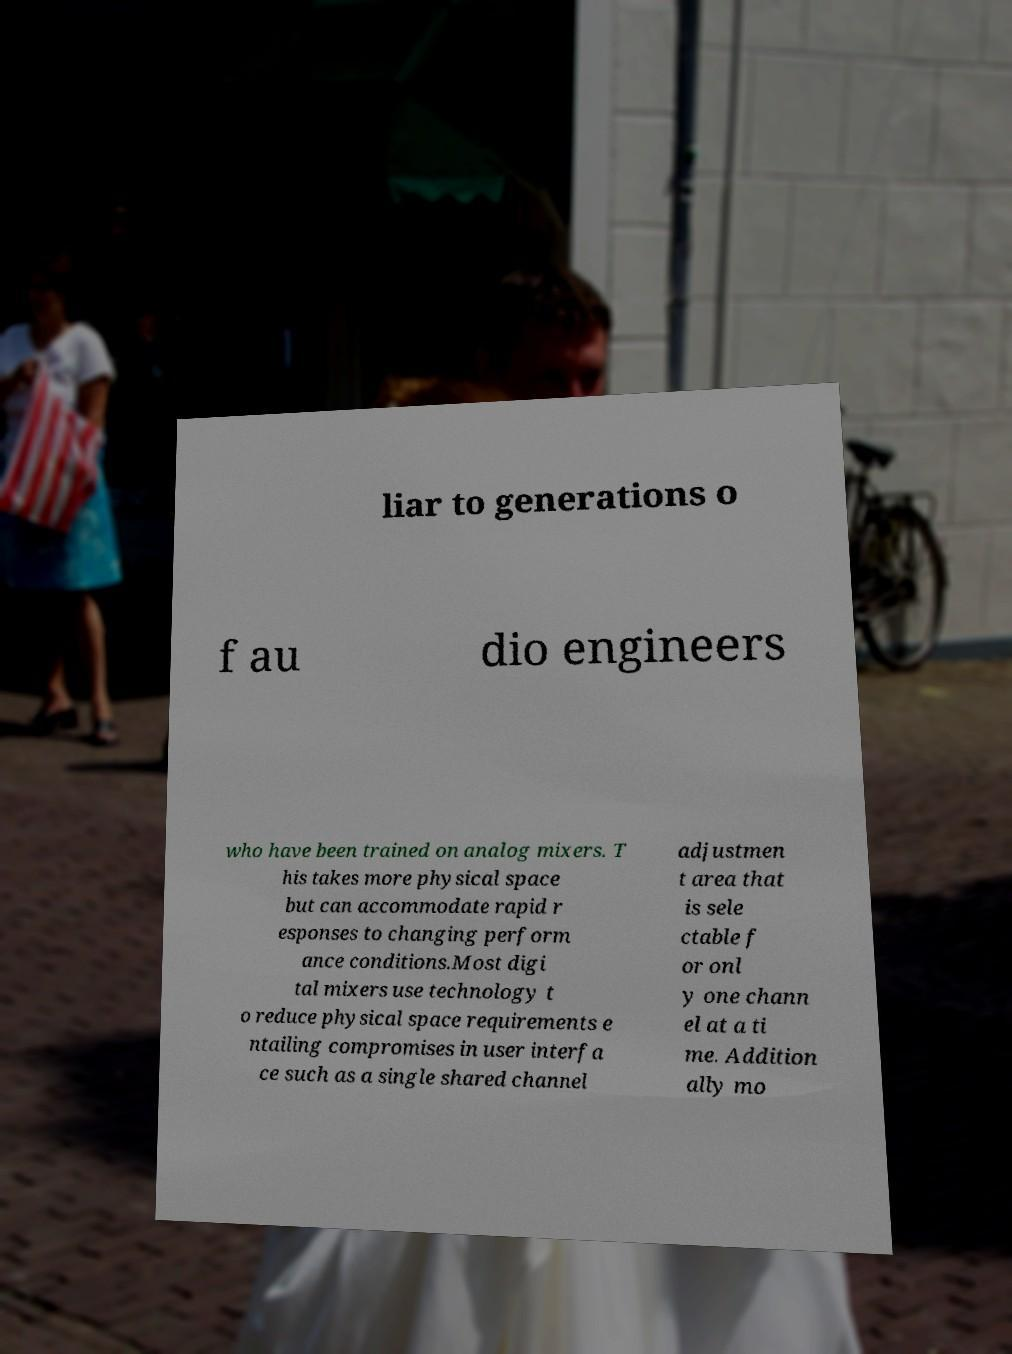Please read and relay the text visible in this image. What does it say? liar to generations o f au dio engineers who have been trained on analog mixers. T his takes more physical space but can accommodate rapid r esponses to changing perform ance conditions.Most digi tal mixers use technology t o reduce physical space requirements e ntailing compromises in user interfa ce such as a single shared channel adjustmen t area that is sele ctable f or onl y one chann el at a ti me. Addition ally mo 